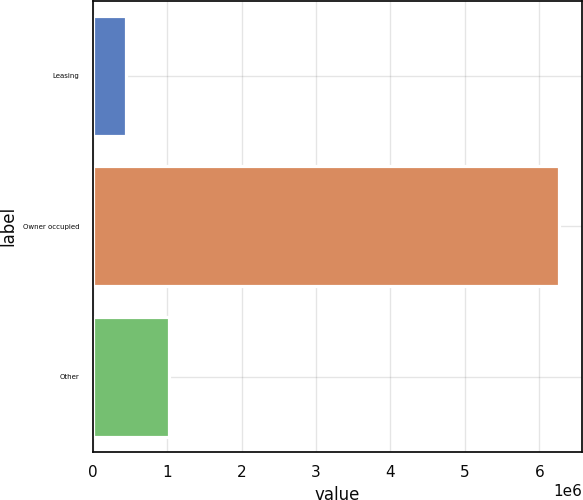Convert chart. <chart><loc_0><loc_0><loc_500><loc_500><bar_chart><fcel>Leasing<fcel>Owner occupied<fcel>Other<nl><fcel>442440<fcel>6.26022e+06<fcel>1.02422e+06<nl></chart> 